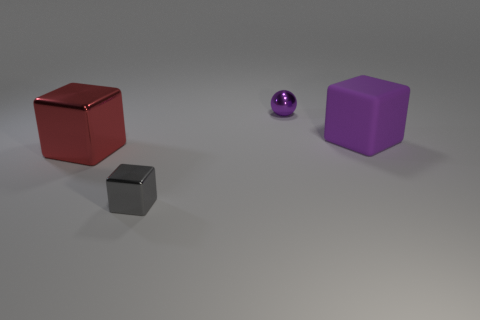Does the small purple ball have the same material as the big purple thing? No, the small purple ball appears to have a reflective, glossy finish, suggesting it might be made of a smooth material like polished metal or glass, while the big purple object has a matte finish which could indicate a material like plastic or rubber. 